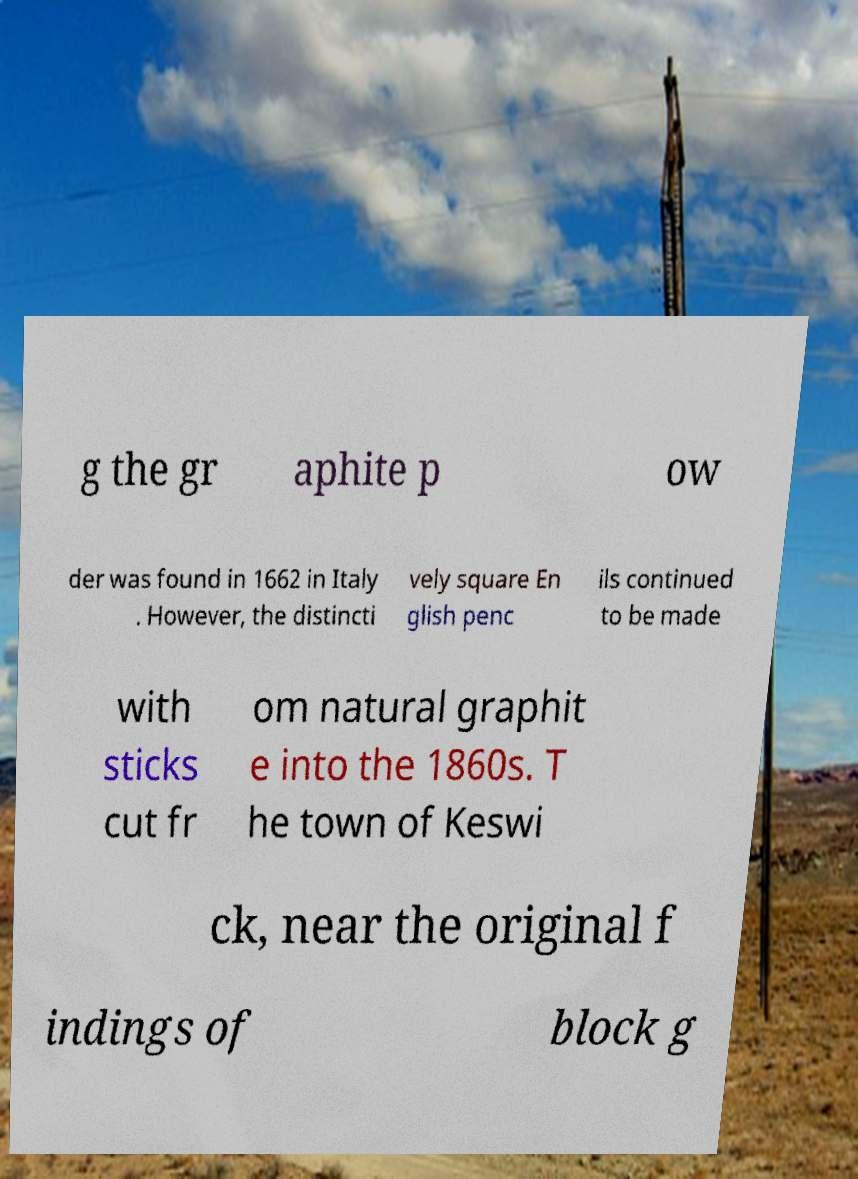What messages or text are displayed in this image? I need them in a readable, typed format. g the gr aphite p ow der was found in 1662 in Italy . However, the distincti vely square En glish penc ils continued to be made with sticks cut fr om natural graphit e into the 1860s. T he town of Keswi ck, near the original f indings of block g 